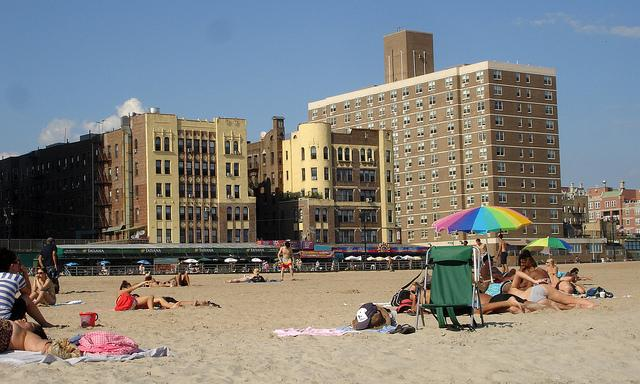Where is someone who might easily overheat safest here? under umbrella 